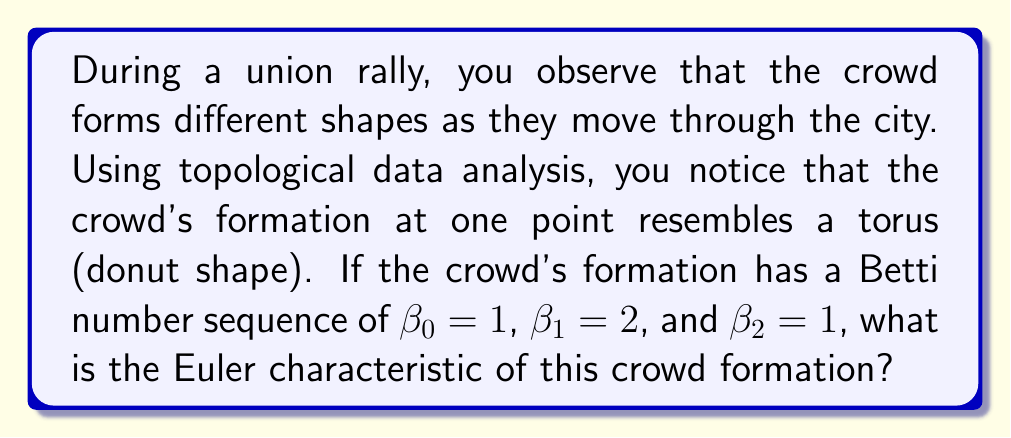Help me with this question. To solve this problem, we need to understand the following concepts:

1. Topological data analysis (TDA) is a method for analyzing complex data sets by focusing on their shape and structure.

2. A torus is a three-dimensional geometric shape that resembles a donut.

3. Betti numbers are topological invariants that describe the connectivity of a space:
   - $\beta_0$ represents the number of connected components
   - $\beta_1$ represents the number of 1-dimensional holes (loops)
   - $\beta_2$ represents the number of 2-dimensional voids (cavities)

4. The Euler characteristic ($\chi$) is a topological invariant that describes the shape of a topological space regardless of how it is bent or stretched.

5. For a topological space, the Euler characteristic can be calculated using the alternating sum of Betti numbers:

   $$\chi = \beta_0 - \beta_1 + \beta_2 - \beta_3 + \cdots$$

Now, let's solve the problem step by step:

1. We are given the Betti numbers:
   $\beta_0 = 1$ (one connected component)
   $\beta_1 = 2$ (two 1-dimensional holes)
   $\beta_2 = 1$ (one 2-dimensional void)

2. We can assume $\beta_3 = 0$ and all higher Betti numbers are also 0, as we are dealing with a 3-dimensional shape.

3. Apply the formula for the Euler characteristic:

   $$\chi = \beta_0 - \beta_1 + \beta_2 - \beta_3 + \cdots$$
   $$\chi = 1 - 2 + 1 - 0$$
   $$\chi = 0$$

Therefore, the Euler characteristic of the crowd formation is 0.
Answer: The Euler characteristic of the crowd formation is 0. 